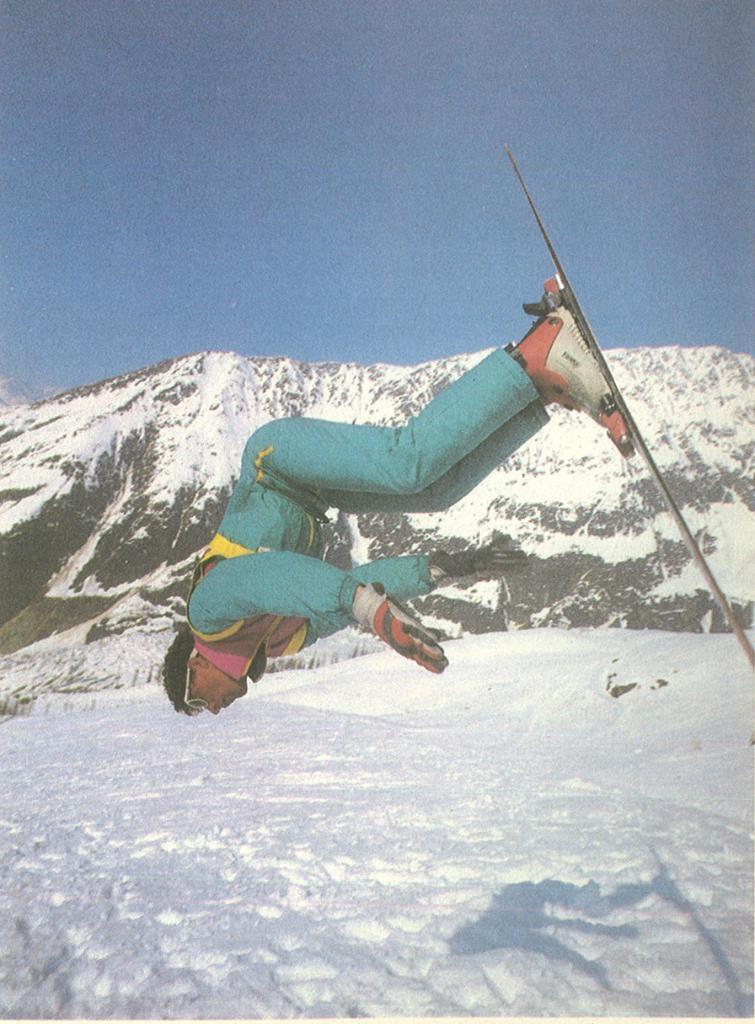How would you summarize this image in a sentence or two? In this picture we can see a man jumping with ski board, the man is wearing costumes, in the bottom we can see snow snow in the background we can see the mountains and also sky. 